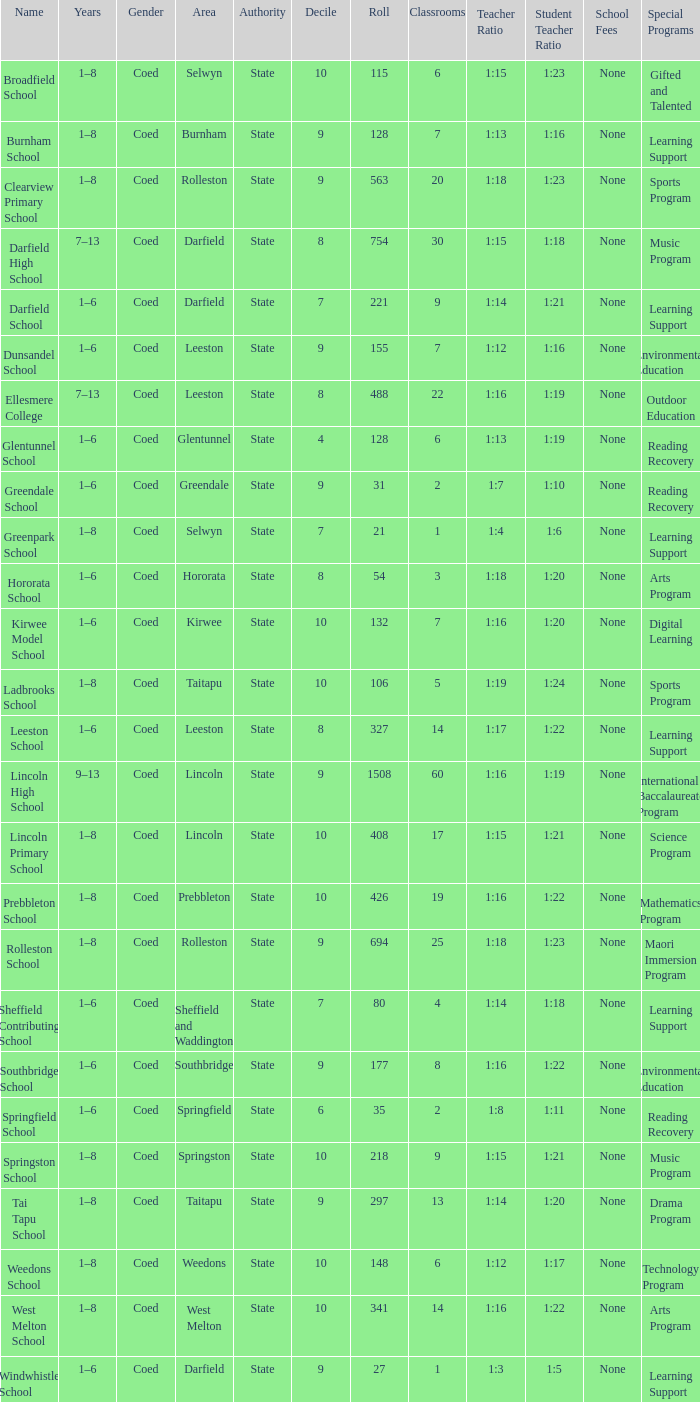What is the name with a Decile less than 10, and a Roll of 297? Tai Tapu School. 